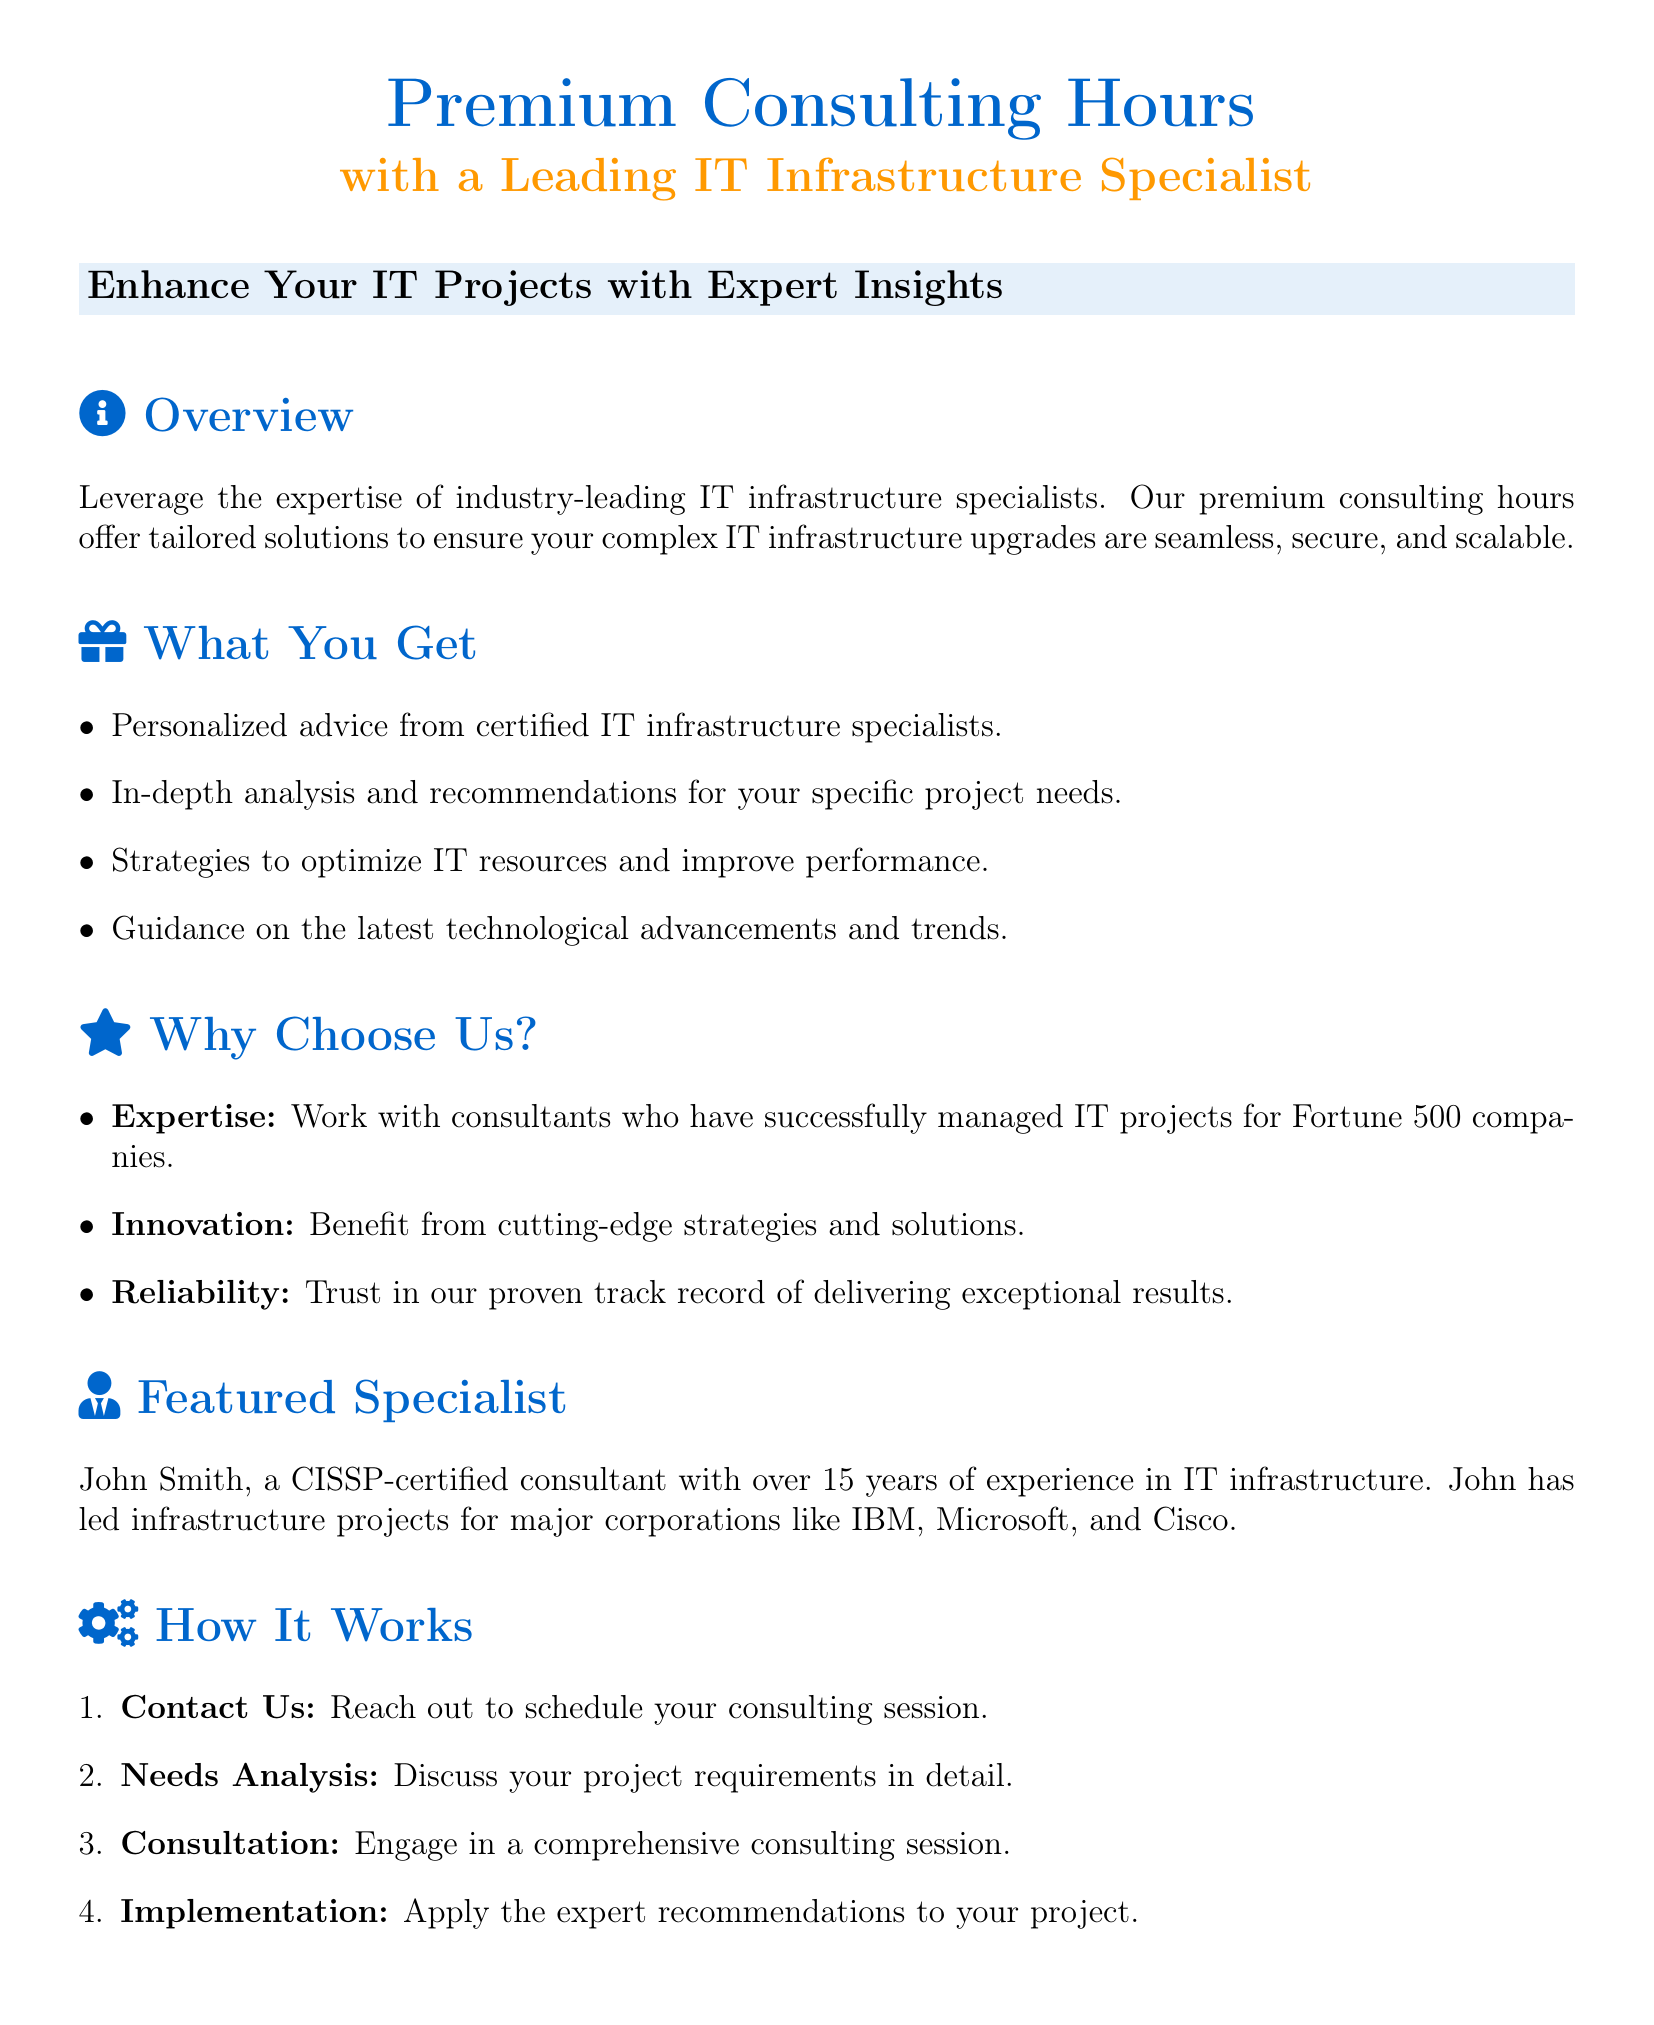What is the title of the document? The title of the document is prominently displayed at the top and represents the main offer.
Answer: Premium Consulting Hours Who is the featured specialist? The document mentions a specific consultant as the featured specialist, noting their experience and certification.
Answer: John Smith How many years of experience does the featured specialist have? The document provides information about the specialist's professional background, which includes their years of experience.
Answer: 15 years What types of insights do the consulting hours aim to provide? The overview section outlines the primary outcome expected from utilizing the consulting hours.
Answer: Expert insights What is one of the reasons to choose this consulting service? The document lists multiple reasons for choosing their consulting service under a specific section.
Answer: Expertise What is the first step in the consulting process? The process section details the initial action required to initiate the consultation.
Answer: Contact Us Which company is mentioned in the testimonials? The testimonials include feedback from individuals associated with specific companies that benefited from the consulting service.
Answer: Tech Innovators LLC What certification does the featured specialist hold? The document specifically notes the qualification of the specialist that assures their credibility and skill.
Answer: CISSP What is the website for booking a session? The document includes contact information for further inquiries, including a website address.
Answer: www.ITConsultingPro.com 